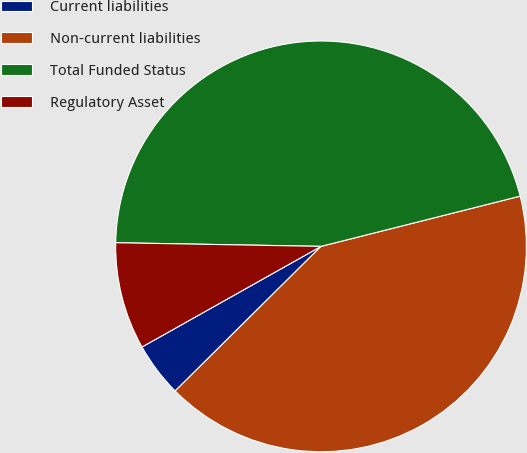Convert chart. <chart><loc_0><loc_0><loc_500><loc_500><pie_chart><fcel>Current liabilities<fcel>Non-current liabilities<fcel>Total Funded Status<fcel>Regulatory Asset<nl><fcel>4.28%<fcel>41.5%<fcel>45.78%<fcel>8.43%<nl></chart> 